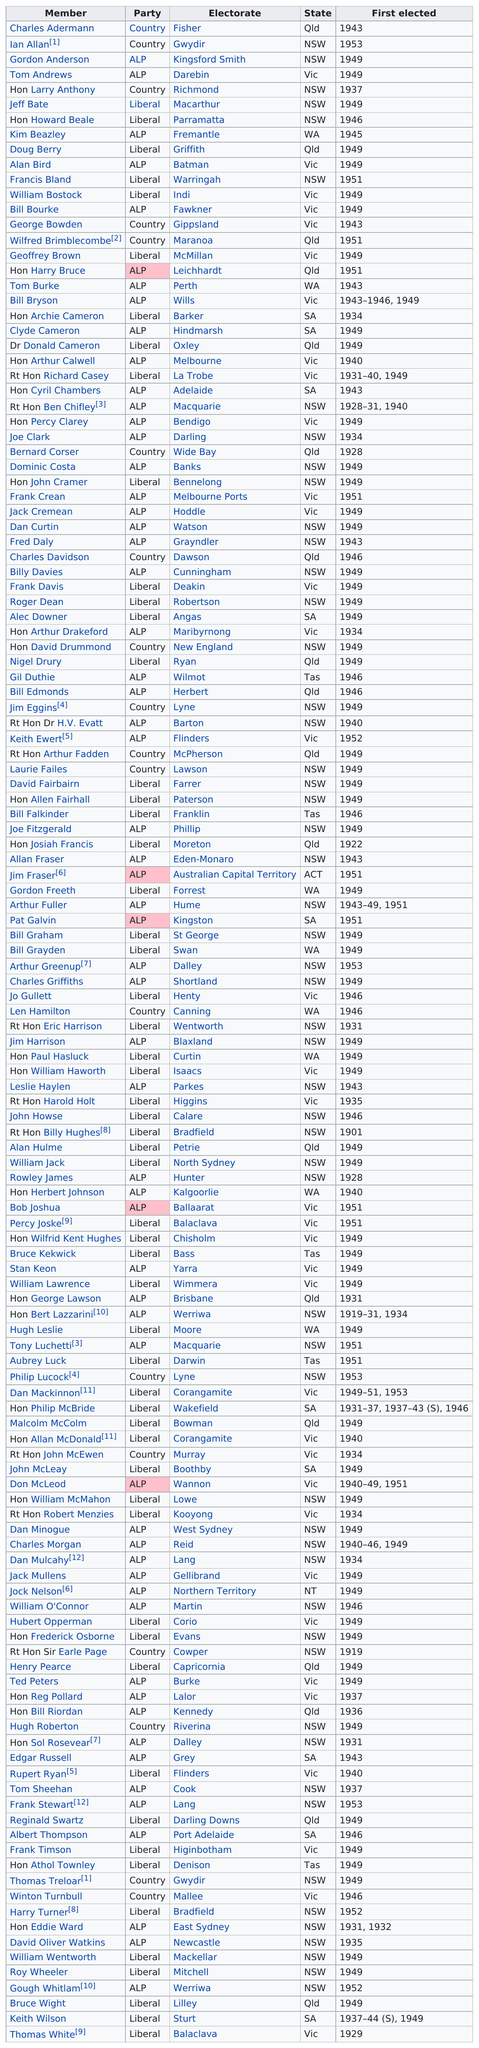Outline some significant characteristics in this image. Allan Fraser was elected for 8 years prior to Frank Crean. Laurie Fails not belong to the ALP and Liberal parties. Sir Earle Page was the only member of the Country Party to be elected in 1919. In the same year as Hon Larry Anthony, Hon Philip McBride and Keith Wilson were also elected as liberal party members. Alan Bird and Billy Davies were both elected to the House of Representatives as members of the Australian Labor Party (ALP). 